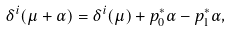<formula> <loc_0><loc_0><loc_500><loc_500>\delta ^ { i } ( \mu + \alpha ) = \delta ^ { i } ( \mu ) + p _ { 0 } ^ { * } \alpha - p _ { 1 } ^ { * } \alpha ,</formula> 